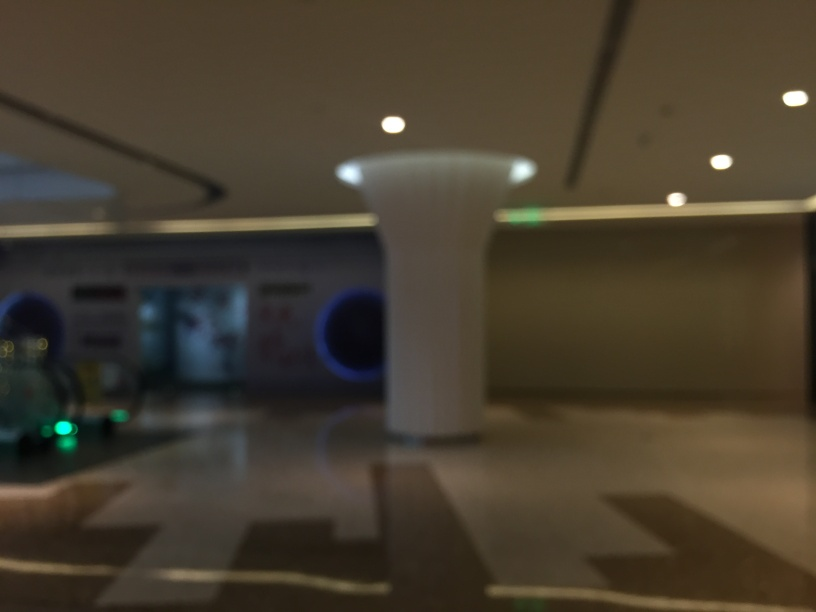Are there any quality issues with this image? Yes, the image suffers from blurriness, making it difficult to clearly distinguish the objects and surroundings. This could be caused by camera movement during exposure, an out-of-focus camera lens, or a low resolution capture. 